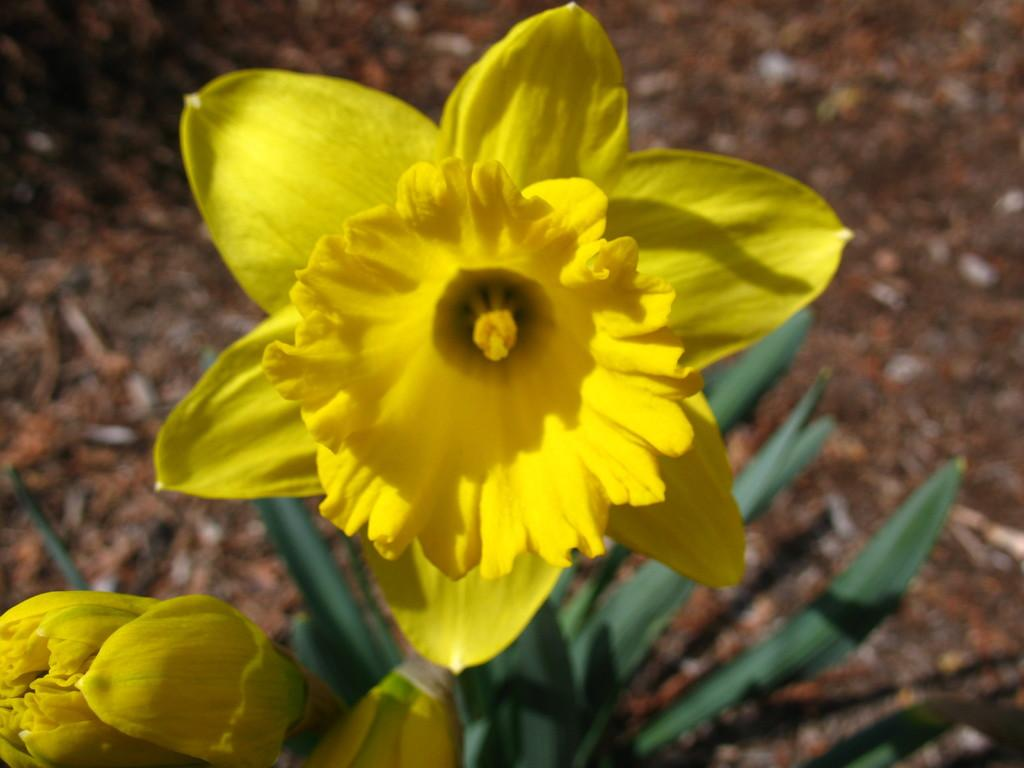What is the main subject in the middle of the image? There is a yellow flower in the middle of the image. Are there any other flowers visible in the image? Yes, there is another flower at the bottom left corner of the image. What else can be seen in the image besides the flowers? There is a plant below the flowers in the image. What type of toys can be seen in the image? There are no toys present in the image; it features flowers and a plant. Is there a cactus visible in the image? There is no cactus present in the image; the plant visible is not a cactus. 